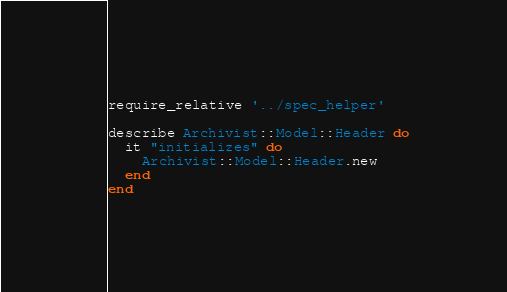Convert code to text. <code><loc_0><loc_0><loc_500><loc_500><_Ruby_>require_relative '../spec_helper'

describe Archivist::Model::Header do
  it "initializes" do
    Archivist::Model::Header.new
  end
end</code> 